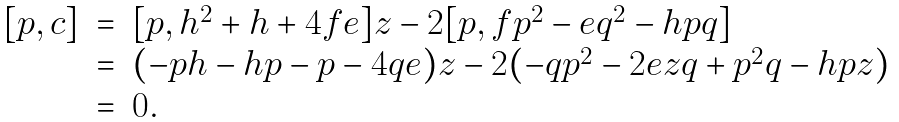Convert formula to latex. <formula><loc_0><loc_0><loc_500><loc_500>\begin{array} { r c l } [ p , c ] & = & [ p , h ^ { 2 } + h + 4 f e ] z - 2 [ p , f p ^ { 2 } - e q ^ { 2 } - h p q ] \\ & = & ( - p h - h p - p - 4 q e ) z - 2 ( - q p ^ { 2 } - 2 e z q + p ^ { 2 } q - h p z ) \\ & = & 0 . \end{array}</formula> 